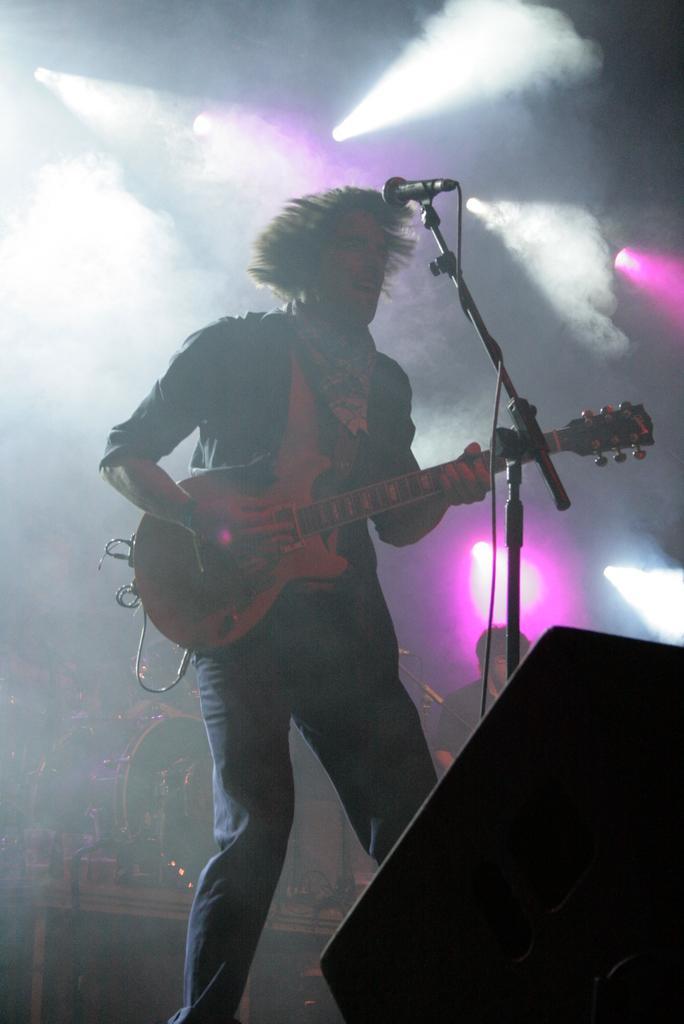In one or two sentences, can you explain what this image depicts? In the image we can see there is a person standing and he is holding a guitar in his hand. There is a mic with a stand in front of him. Behind there is another person standing. 